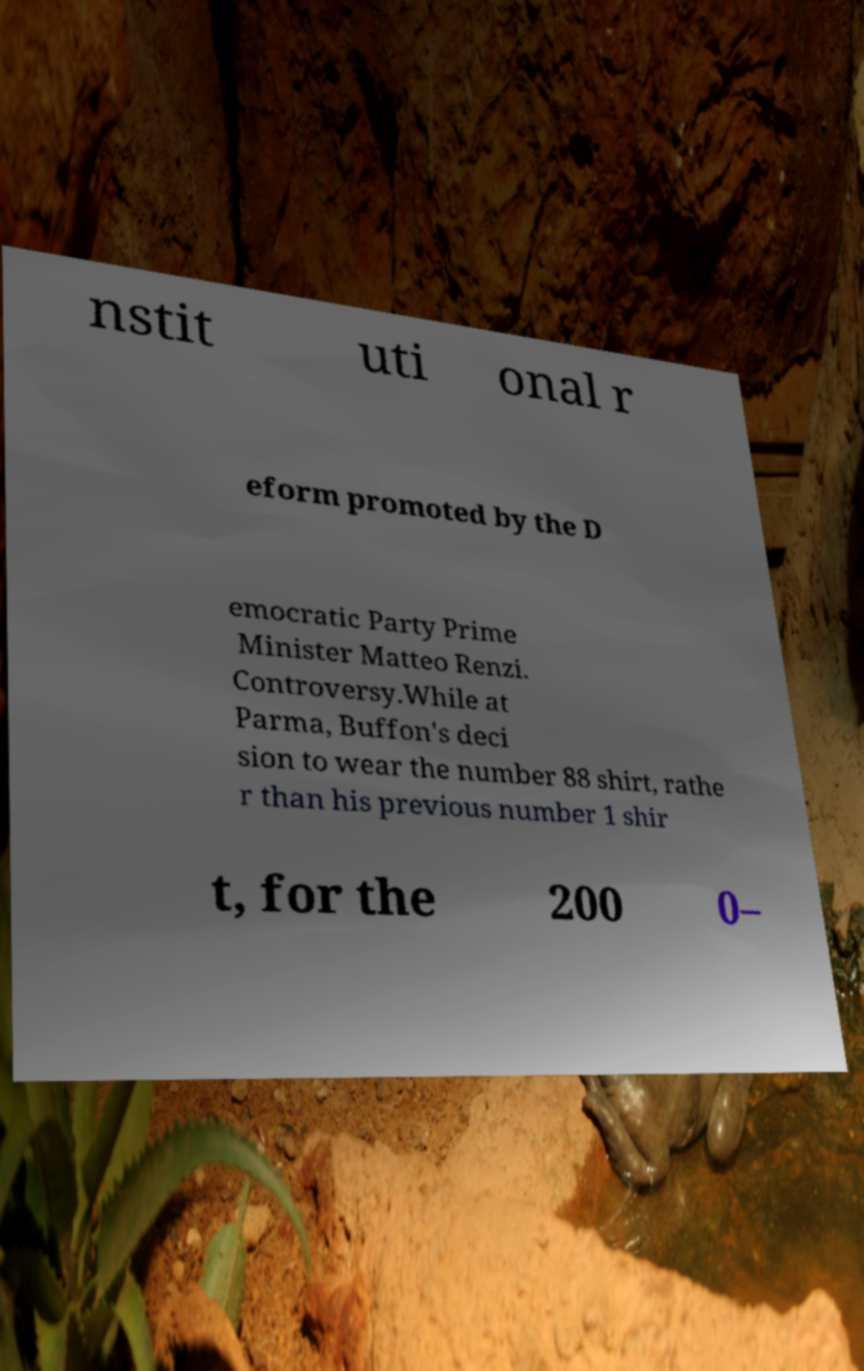Please read and relay the text visible in this image. What does it say? nstit uti onal r eform promoted by the D emocratic Party Prime Minister Matteo Renzi. Controversy.While at Parma, Buffon's deci sion to wear the number 88 shirt, rathe r than his previous number 1 shir t, for the 200 0– 